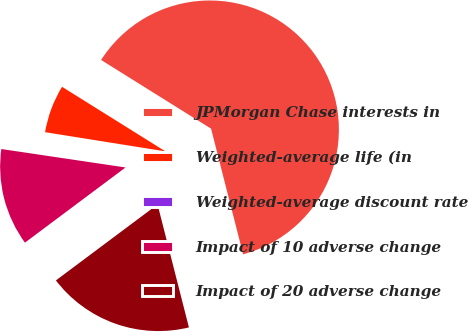Convert chart to OTSL. <chart><loc_0><loc_0><loc_500><loc_500><pie_chart><fcel>JPMorgan Chase interests in<fcel>Weighted-average life (in<fcel>Weighted-average discount rate<fcel>Impact of 10 adverse change<fcel>Impact of 20 adverse change<nl><fcel>62.14%<fcel>6.37%<fcel>0.17%<fcel>12.56%<fcel>18.76%<nl></chart> 